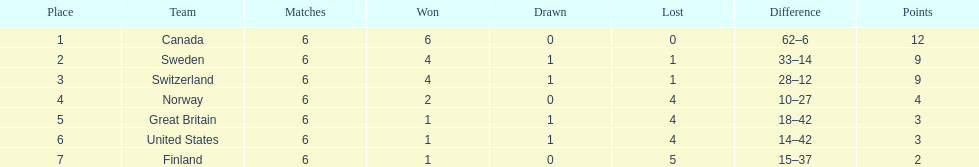What team placed next after sweden? Switzerland. 